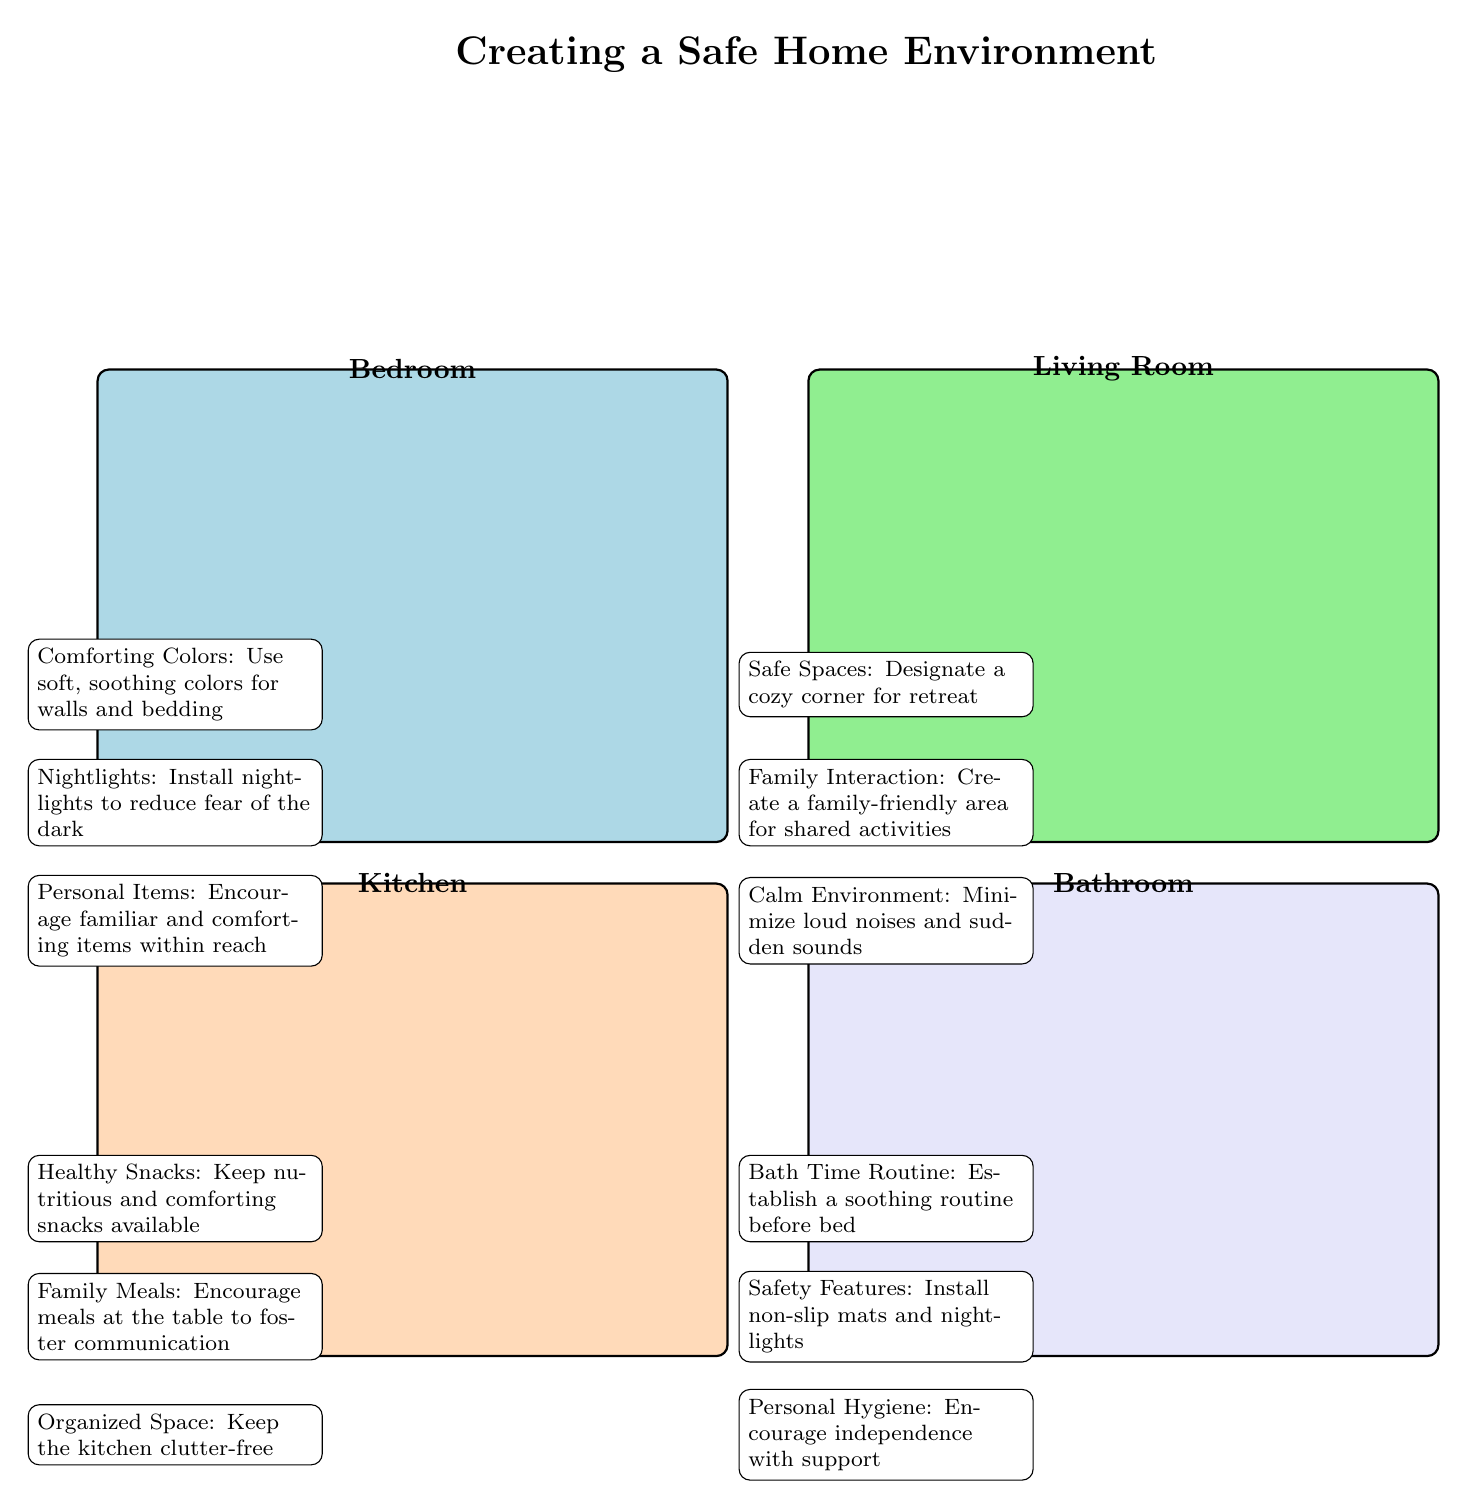What color should the bedroom walls be? The diagram indicates that the bedroom should use soft, soothing colors for walls and bedding, as labeled by the annotation.
Answer: Soft, soothing colors How many rooms are illustrated in the diagram? The diagram shows a total of four rooms: Bedroom, Living Room, Kitchen, and Bathroom. By counting the distinct colored areas, we confirm this total.
Answer: Four What feature is suggested to help with fear of the dark in the bedroom? The annotation in the bedroom section specifically mentions installing nightlights, which directly addresses nighttime fears.
Answer: Nightlights What is a recommended kitchen feature to encourage communication? According to the annotation in the kitchen area, sharing meals at the table fosters communication among family members.
Answer: Family Meals What calming measure is suggested for the living room? The diagram points out that minimizing loud noises and sudden sounds creates a calm environment, which is essential for comfort.
Answer: Calm Environment Which room promotes independent hygiene with support? The bathroom annotation encourages personal hygiene independence, indicating this is a focus in the bathroom area.
Answer: Bathroom How should the living room be organized to provide comfort? The diagram suggests designating a cozy corner in the living room for retreat, providing a safe space where the child can feel comfortable.
Answer: Cozy corner What item keeps the kitchen organized? The diagram mentions keeping the kitchen clutter-free as an organizational measure. This supports a feeling of safety and comfort.
Answer: Organized Space What does the bathroom recommend for a soothing routine? The annotation specifies establishing a soothing bath time routine before bed in the bathroom area to promote relaxation.
Answer: Bath Time Routine 